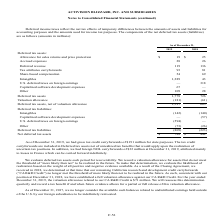According to Activision Blizzard's financial document, What was the amount of gross tax credit carryforwards for state purposes in 2019? According to the financial document, $191 million. The relevant text states: "31, 2019, we had gross tax credit carryforwards of $191 million for state purposes. The tax credit..." Also, What was the deferred revenue in 2019? According to the financial document, 119 (in millions). The relevant text states: "Deferred revenue 119 136..." Also, What was the accrued expenses in 2018? According to the financial document, 26 (in millions). The relevant text states: "Accrued expenses 28 26..." Also, can you calculate: What was the percentage change in accrued expenses between 2018 and 2019? To answer this question, I need to perform calculations using the financial data. The calculation is: (28-26)/26, which equals 7.69 (percentage). This is based on the information: "Accrued expenses 28 26 Accrued expenses 28 26..." The key data points involved are: 26, 28. Also, can you calculate: What was the percentage change in intangibles between 2018 and 2019? To answer this question, I need to perform calculations using the financial data. The calculation is: (1,289-43)/43, which equals 2897.67 (percentage). This is based on the information: "Intangibles 1,289 43 Intangibles 1,289 43..." The key data points involved are: 1,289, 43. Also, can you calculate: What was the change in net deferred tax assets between 2018 and 2019? Based on the calculation: ($788-$442), the result is 346 (in millions). This is based on the information: "Net deferred tax assets $ 788 $ 442 Net deferred tax assets $ 788 $ 442..." The key data points involved are: 442, 788. 